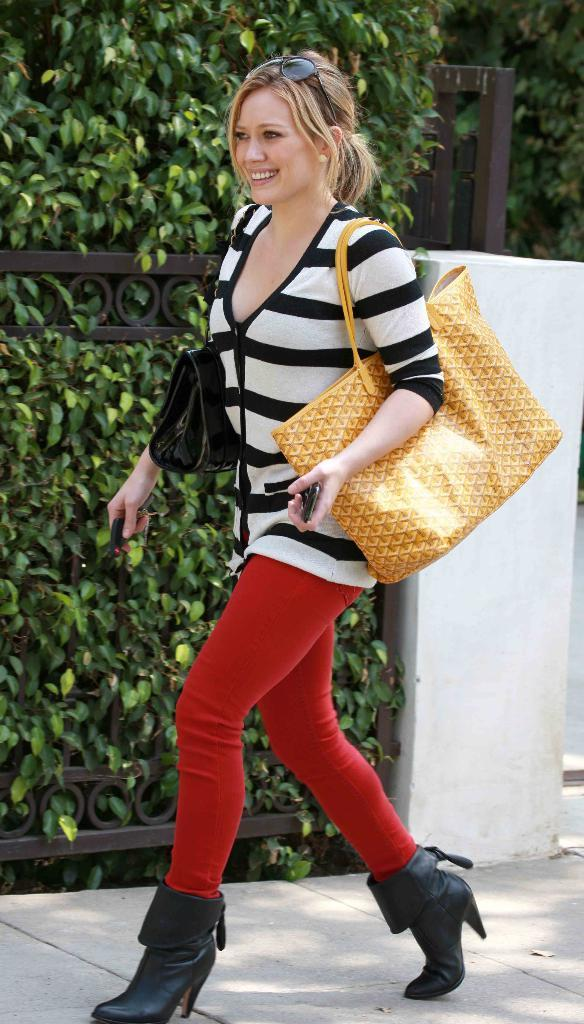Who is present in the image? There is a woman in the image. What is the woman doing in the image? The woman is walking on a footpath in the image. What is the woman wearing that is yellow? The woman is wearing a yellow bag in the image. What object is the woman holding in her hand? The woman is holding a mobile phone in her hand in the image. What type of ants can be seen crawling on the woman's shoes in the image? There are no ants present in the image; the woman is walking on a footpath without any visible ants. 